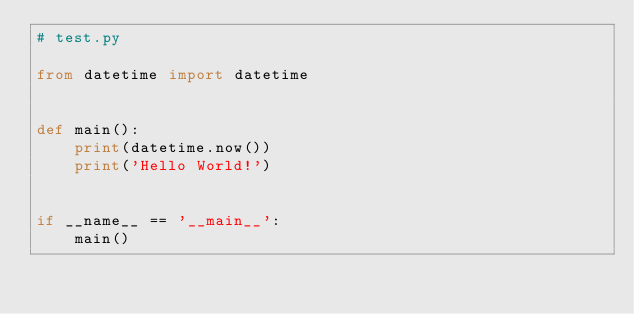<code> <loc_0><loc_0><loc_500><loc_500><_Python_># test.py

from datetime import datetime


def main():
    print(datetime.now())
    print('Hello World!')


if __name__ == '__main__':
    main()
</code> 